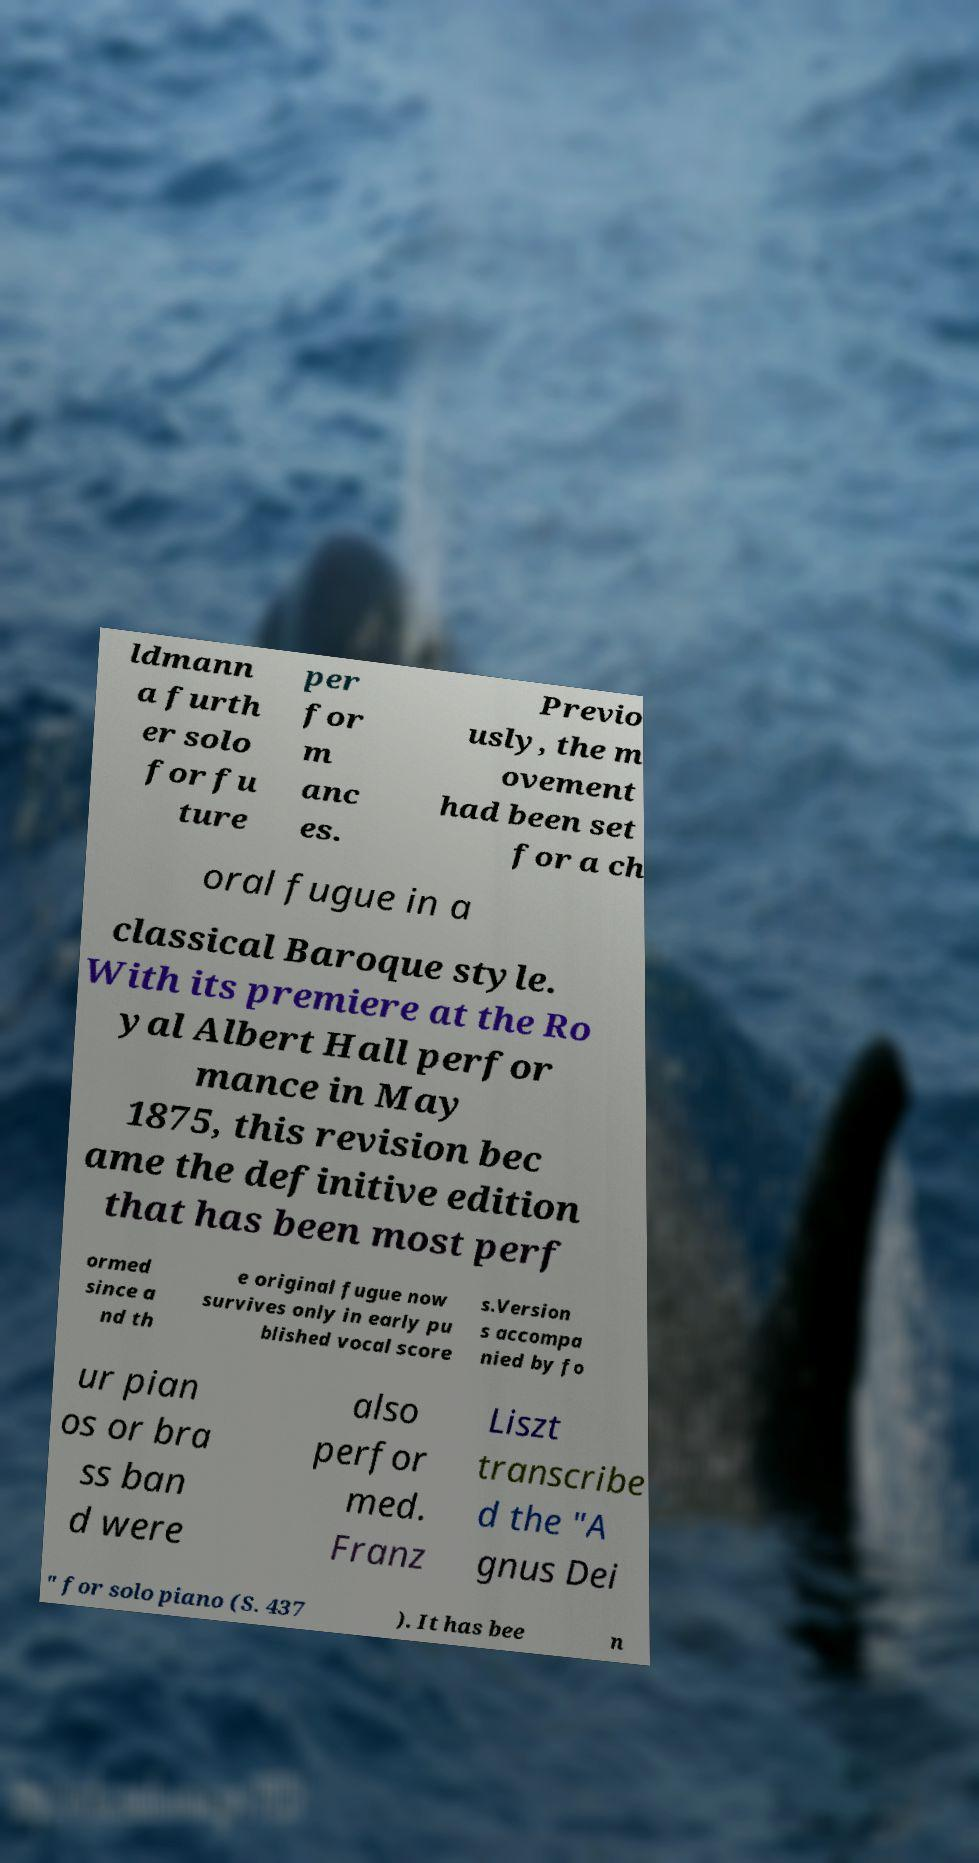What messages or text are displayed in this image? I need them in a readable, typed format. ldmann a furth er solo for fu ture per for m anc es. Previo usly, the m ovement had been set for a ch oral fugue in a classical Baroque style. With its premiere at the Ro yal Albert Hall perfor mance in May 1875, this revision bec ame the definitive edition that has been most perf ormed since a nd th e original fugue now survives only in early pu blished vocal score s.Version s accompa nied by fo ur pian os or bra ss ban d were also perfor med. Franz Liszt transcribe d the "A gnus Dei " for solo piano (S. 437 ). It has bee n 